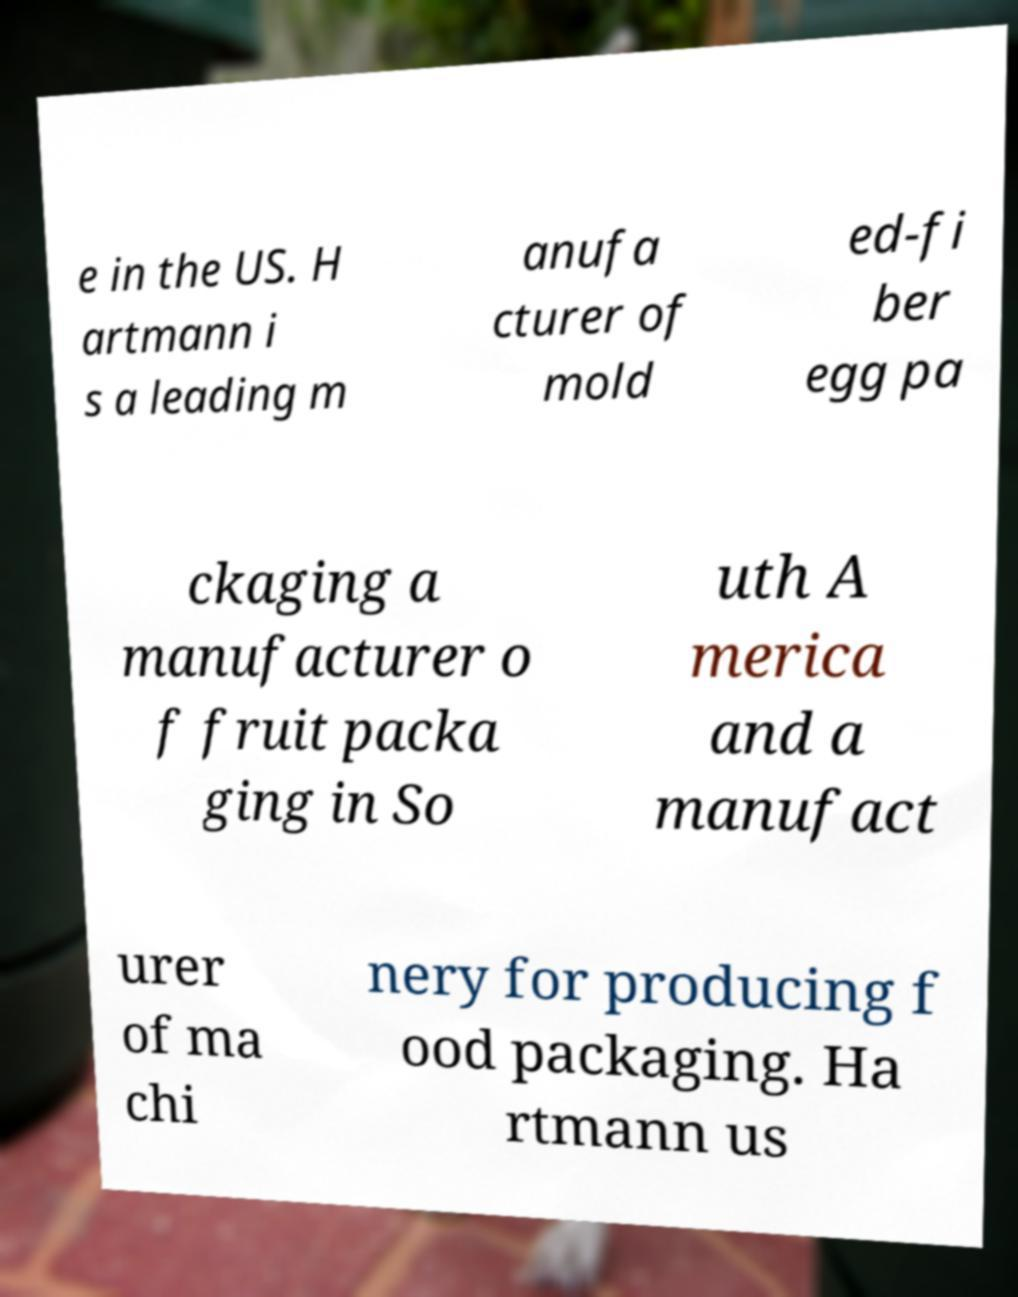I need the written content from this picture converted into text. Can you do that? e in the US. H artmann i s a leading m anufa cturer of mold ed-fi ber egg pa ckaging a manufacturer o f fruit packa ging in So uth A merica and a manufact urer of ma chi nery for producing f ood packaging. Ha rtmann us 